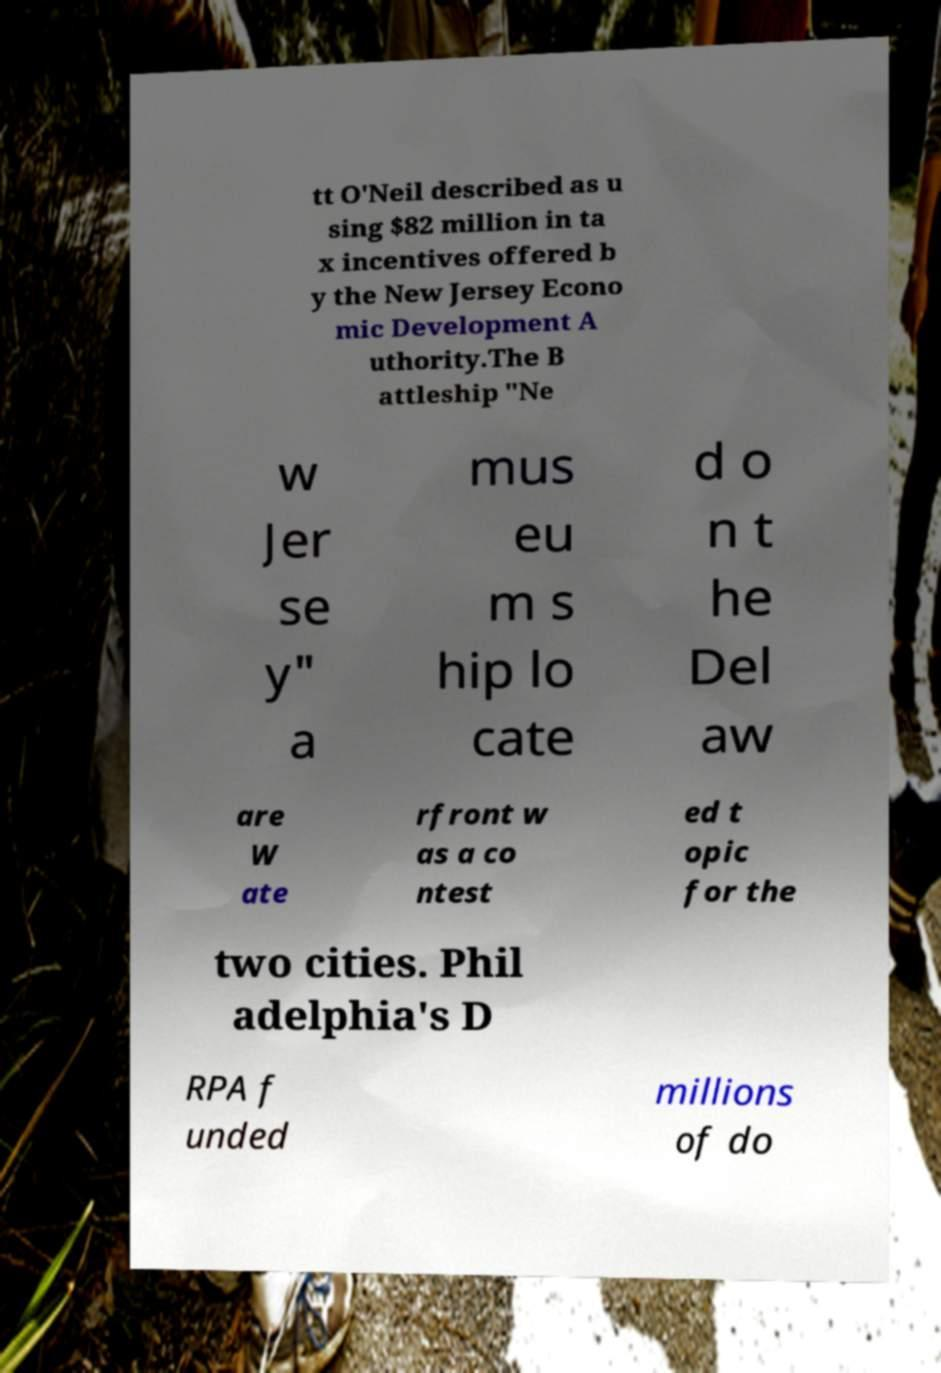Please identify and transcribe the text found in this image. tt O'Neil described as u sing $82 million in ta x incentives offered b y the New Jersey Econo mic Development A uthority.The B attleship "Ne w Jer se y" a mus eu m s hip lo cate d o n t he Del aw are W ate rfront w as a co ntest ed t opic for the two cities. Phil adelphia's D RPA f unded millions of do 